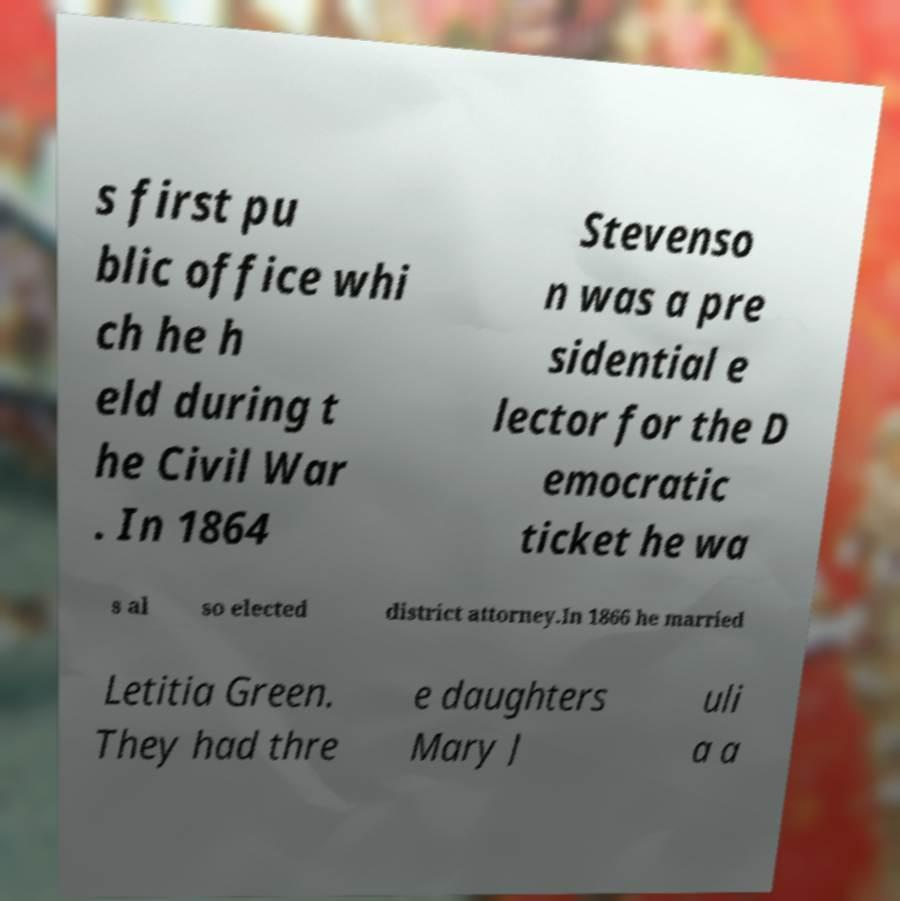Please identify and transcribe the text found in this image. s first pu blic office whi ch he h eld during t he Civil War . In 1864 Stevenso n was a pre sidential e lector for the D emocratic ticket he wa s al so elected district attorney.In 1866 he married Letitia Green. They had thre e daughters Mary J uli a a 